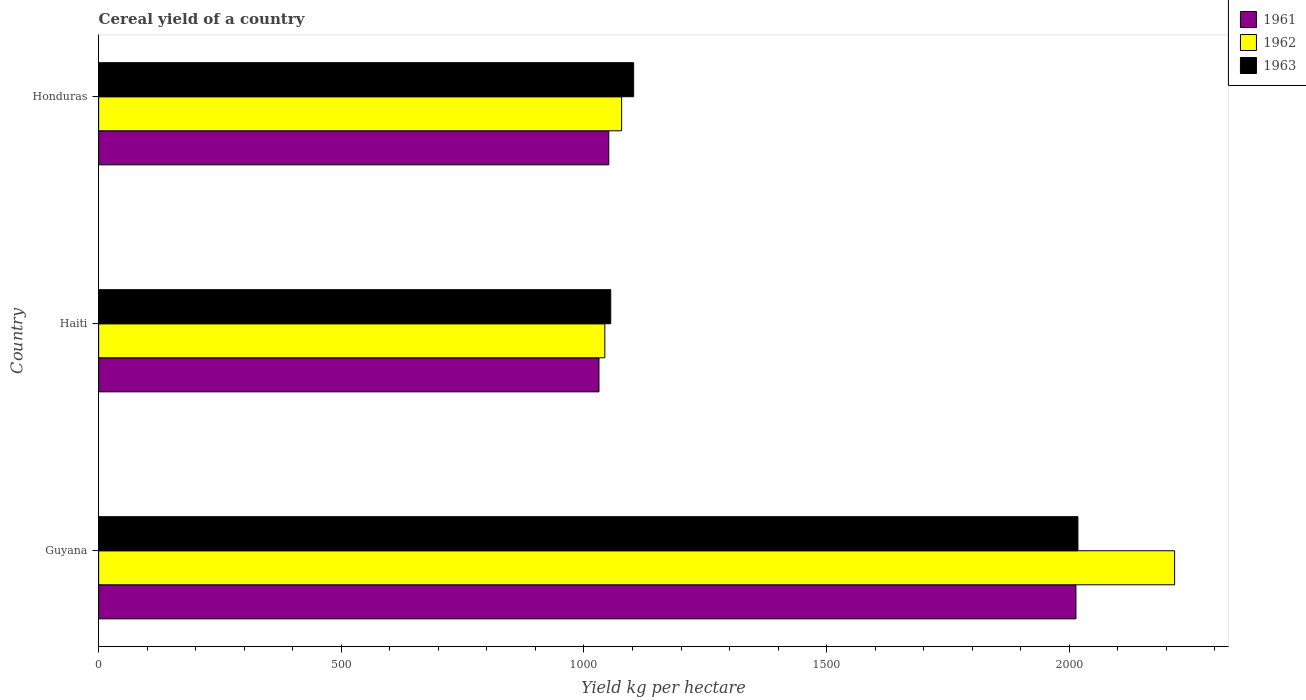How many different coloured bars are there?
Offer a terse response. 3. What is the label of the 1st group of bars from the top?
Your answer should be very brief. Honduras. In how many cases, is the number of bars for a given country not equal to the number of legend labels?
Your answer should be compact. 0. What is the total cereal yield in 1961 in Honduras?
Your response must be concise. 1051.18. Across all countries, what is the maximum total cereal yield in 1961?
Keep it short and to the point. 2013.78. Across all countries, what is the minimum total cereal yield in 1962?
Ensure brevity in your answer.  1043.05. In which country was the total cereal yield in 1962 maximum?
Ensure brevity in your answer.  Guyana. In which country was the total cereal yield in 1962 minimum?
Your response must be concise. Haiti. What is the total total cereal yield in 1963 in the graph?
Give a very brief answer. 4175.46. What is the difference between the total cereal yield in 1962 in Guyana and that in Honduras?
Ensure brevity in your answer.  1139.53. What is the difference between the total cereal yield in 1963 in Guyana and the total cereal yield in 1961 in Haiti?
Give a very brief answer. 986.9. What is the average total cereal yield in 1961 per country?
Your answer should be compact. 1365.31. What is the difference between the total cereal yield in 1962 and total cereal yield in 1961 in Honduras?
Give a very brief answer. 26.43. In how many countries, is the total cereal yield in 1963 greater than 1000 kg per hectare?
Your response must be concise. 3. What is the ratio of the total cereal yield in 1962 in Guyana to that in Haiti?
Your answer should be compact. 2.13. Is the difference between the total cereal yield in 1962 in Haiti and Honduras greater than the difference between the total cereal yield in 1961 in Haiti and Honduras?
Provide a succinct answer. No. What is the difference between the highest and the second highest total cereal yield in 1962?
Keep it short and to the point. 1139.53. What is the difference between the highest and the lowest total cereal yield in 1963?
Ensure brevity in your answer.  962.68. In how many countries, is the total cereal yield in 1961 greater than the average total cereal yield in 1961 taken over all countries?
Your response must be concise. 1. What does the 3rd bar from the bottom in Haiti represents?
Keep it short and to the point. 1963. Is it the case that in every country, the sum of the total cereal yield in 1963 and total cereal yield in 1961 is greater than the total cereal yield in 1962?
Offer a terse response. Yes. How many countries are there in the graph?
Provide a short and direct response. 3. Are the values on the major ticks of X-axis written in scientific E-notation?
Ensure brevity in your answer.  No. Does the graph contain any zero values?
Your response must be concise. No. Does the graph contain grids?
Your answer should be very brief. No. Where does the legend appear in the graph?
Keep it short and to the point. Top right. How many legend labels are there?
Your response must be concise. 3. How are the legend labels stacked?
Keep it short and to the point. Vertical. What is the title of the graph?
Your answer should be very brief. Cereal yield of a country. Does "1964" appear as one of the legend labels in the graph?
Your response must be concise. No. What is the label or title of the X-axis?
Your answer should be compact. Yield kg per hectare. What is the label or title of the Y-axis?
Your response must be concise. Country. What is the Yield kg per hectare of 1961 in Guyana?
Your answer should be compact. 2013.78. What is the Yield kg per hectare in 1962 in Guyana?
Provide a short and direct response. 2217.15. What is the Yield kg per hectare in 1963 in Guyana?
Offer a very short reply. 2017.87. What is the Yield kg per hectare in 1961 in Haiti?
Provide a succinct answer. 1030.97. What is the Yield kg per hectare in 1962 in Haiti?
Offer a very short reply. 1043.05. What is the Yield kg per hectare of 1963 in Haiti?
Make the answer very short. 1055.19. What is the Yield kg per hectare in 1961 in Honduras?
Keep it short and to the point. 1051.18. What is the Yield kg per hectare of 1962 in Honduras?
Provide a short and direct response. 1077.62. What is the Yield kg per hectare of 1963 in Honduras?
Keep it short and to the point. 1102.4. Across all countries, what is the maximum Yield kg per hectare of 1961?
Your response must be concise. 2013.78. Across all countries, what is the maximum Yield kg per hectare of 1962?
Your answer should be compact. 2217.15. Across all countries, what is the maximum Yield kg per hectare of 1963?
Provide a succinct answer. 2017.87. Across all countries, what is the minimum Yield kg per hectare of 1961?
Provide a short and direct response. 1030.97. Across all countries, what is the minimum Yield kg per hectare of 1962?
Your answer should be very brief. 1043.05. Across all countries, what is the minimum Yield kg per hectare in 1963?
Provide a short and direct response. 1055.19. What is the total Yield kg per hectare of 1961 in the graph?
Ensure brevity in your answer.  4095.94. What is the total Yield kg per hectare of 1962 in the graph?
Offer a terse response. 4337.81. What is the total Yield kg per hectare in 1963 in the graph?
Provide a succinct answer. 4175.46. What is the difference between the Yield kg per hectare in 1961 in Guyana and that in Haiti?
Your response must be concise. 982.81. What is the difference between the Yield kg per hectare in 1962 in Guyana and that in Haiti?
Ensure brevity in your answer.  1174.1. What is the difference between the Yield kg per hectare of 1963 in Guyana and that in Haiti?
Provide a succinct answer. 962.68. What is the difference between the Yield kg per hectare of 1961 in Guyana and that in Honduras?
Make the answer very short. 962.6. What is the difference between the Yield kg per hectare in 1962 in Guyana and that in Honduras?
Make the answer very short. 1139.53. What is the difference between the Yield kg per hectare in 1963 in Guyana and that in Honduras?
Your answer should be compact. 915.48. What is the difference between the Yield kg per hectare in 1961 in Haiti and that in Honduras?
Provide a short and direct response. -20.21. What is the difference between the Yield kg per hectare of 1962 in Haiti and that in Honduras?
Provide a succinct answer. -34.57. What is the difference between the Yield kg per hectare of 1963 in Haiti and that in Honduras?
Your answer should be very brief. -47.21. What is the difference between the Yield kg per hectare of 1961 in Guyana and the Yield kg per hectare of 1962 in Haiti?
Offer a very short reply. 970.74. What is the difference between the Yield kg per hectare of 1961 in Guyana and the Yield kg per hectare of 1963 in Haiti?
Your response must be concise. 958.59. What is the difference between the Yield kg per hectare in 1962 in Guyana and the Yield kg per hectare in 1963 in Haiti?
Your answer should be very brief. 1161.96. What is the difference between the Yield kg per hectare of 1961 in Guyana and the Yield kg per hectare of 1962 in Honduras?
Offer a very short reply. 936.16. What is the difference between the Yield kg per hectare in 1961 in Guyana and the Yield kg per hectare in 1963 in Honduras?
Your answer should be compact. 911.38. What is the difference between the Yield kg per hectare in 1962 in Guyana and the Yield kg per hectare in 1963 in Honduras?
Provide a short and direct response. 1114.75. What is the difference between the Yield kg per hectare of 1961 in Haiti and the Yield kg per hectare of 1962 in Honduras?
Provide a short and direct response. -46.64. What is the difference between the Yield kg per hectare of 1961 in Haiti and the Yield kg per hectare of 1963 in Honduras?
Keep it short and to the point. -71.42. What is the difference between the Yield kg per hectare of 1962 in Haiti and the Yield kg per hectare of 1963 in Honduras?
Your answer should be very brief. -59.35. What is the average Yield kg per hectare in 1961 per country?
Your response must be concise. 1365.31. What is the average Yield kg per hectare in 1962 per country?
Give a very brief answer. 1445.94. What is the average Yield kg per hectare in 1963 per country?
Your response must be concise. 1391.82. What is the difference between the Yield kg per hectare of 1961 and Yield kg per hectare of 1962 in Guyana?
Make the answer very short. -203.37. What is the difference between the Yield kg per hectare in 1961 and Yield kg per hectare in 1963 in Guyana?
Offer a very short reply. -4.09. What is the difference between the Yield kg per hectare in 1962 and Yield kg per hectare in 1963 in Guyana?
Give a very brief answer. 199.28. What is the difference between the Yield kg per hectare in 1961 and Yield kg per hectare in 1962 in Haiti?
Give a very brief answer. -12.07. What is the difference between the Yield kg per hectare in 1961 and Yield kg per hectare in 1963 in Haiti?
Your response must be concise. -24.21. What is the difference between the Yield kg per hectare of 1962 and Yield kg per hectare of 1963 in Haiti?
Provide a short and direct response. -12.14. What is the difference between the Yield kg per hectare of 1961 and Yield kg per hectare of 1962 in Honduras?
Offer a terse response. -26.43. What is the difference between the Yield kg per hectare in 1961 and Yield kg per hectare in 1963 in Honduras?
Your answer should be very brief. -51.21. What is the difference between the Yield kg per hectare of 1962 and Yield kg per hectare of 1963 in Honduras?
Make the answer very short. -24.78. What is the ratio of the Yield kg per hectare in 1961 in Guyana to that in Haiti?
Offer a terse response. 1.95. What is the ratio of the Yield kg per hectare in 1962 in Guyana to that in Haiti?
Offer a terse response. 2.13. What is the ratio of the Yield kg per hectare in 1963 in Guyana to that in Haiti?
Make the answer very short. 1.91. What is the ratio of the Yield kg per hectare of 1961 in Guyana to that in Honduras?
Your response must be concise. 1.92. What is the ratio of the Yield kg per hectare of 1962 in Guyana to that in Honduras?
Make the answer very short. 2.06. What is the ratio of the Yield kg per hectare of 1963 in Guyana to that in Honduras?
Provide a succinct answer. 1.83. What is the ratio of the Yield kg per hectare in 1961 in Haiti to that in Honduras?
Your answer should be very brief. 0.98. What is the ratio of the Yield kg per hectare in 1962 in Haiti to that in Honduras?
Provide a short and direct response. 0.97. What is the ratio of the Yield kg per hectare in 1963 in Haiti to that in Honduras?
Keep it short and to the point. 0.96. What is the difference between the highest and the second highest Yield kg per hectare in 1961?
Provide a short and direct response. 962.6. What is the difference between the highest and the second highest Yield kg per hectare of 1962?
Your answer should be very brief. 1139.53. What is the difference between the highest and the second highest Yield kg per hectare in 1963?
Ensure brevity in your answer.  915.48. What is the difference between the highest and the lowest Yield kg per hectare in 1961?
Make the answer very short. 982.81. What is the difference between the highest and the lowest Yield kg per hectare in 1962?
Your answer should be very brief. 1174.1. What is the difference between the highest and the lowest Yield kg per hectare in 1963?
Ensure brevity in your answer.  962.68. 